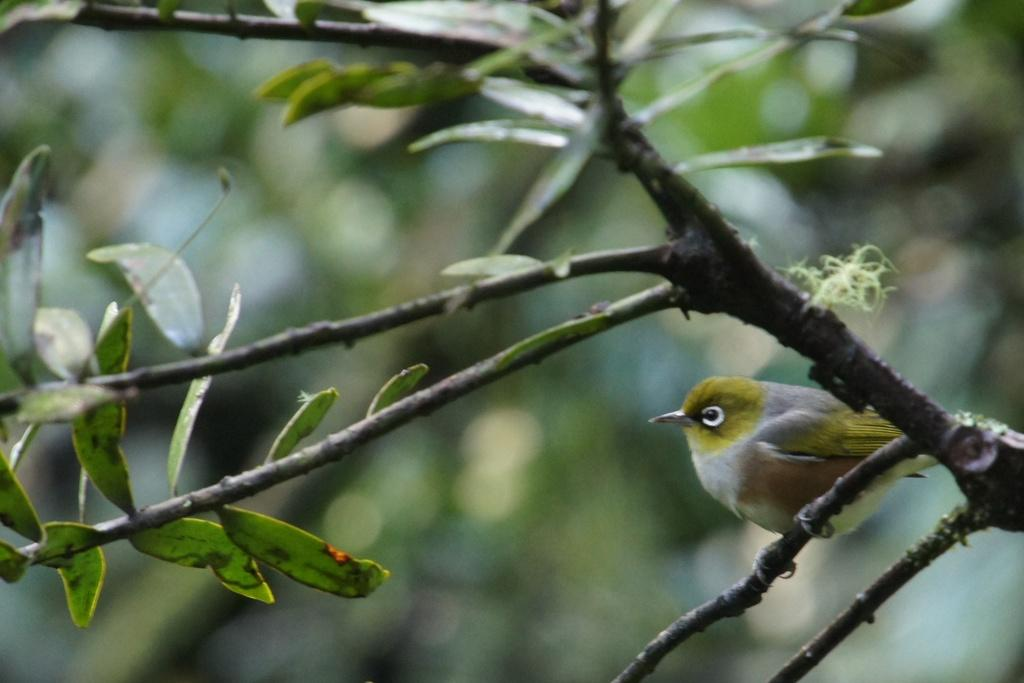What type of animal can be seen in the image? There is a bird in the image. Where is the bird located in the image? The bird is sitting on a branch of a plant. What type of clam is visible in the image? There is no clam present in the image; it features a bird sitting on a branch of a plant. How many trains can be seen in the image? There are no trains present in the image. 